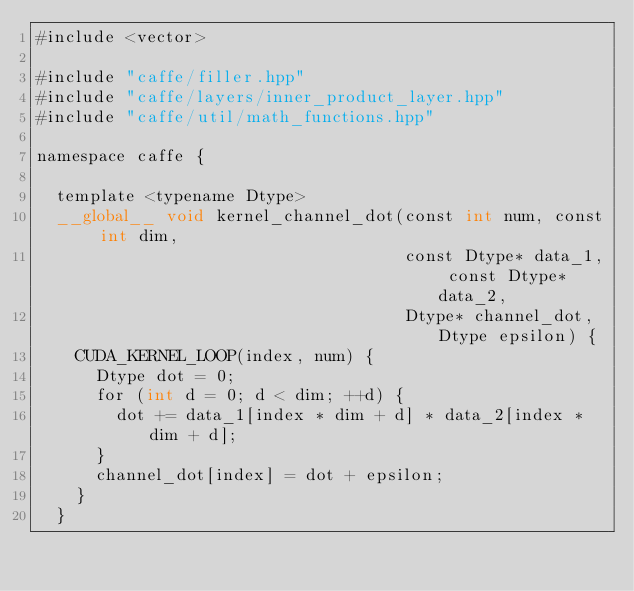<code> <loc_0><loc_0><loc_500><loc_500><_Cuda_>#include <vector>

#include "caffe/filler.hpp"
#include "caffe/layers/inner_product_layer.hpp"
#include "caffe/util/math_functions.hpp"

namespace caffe {

  template <typename Dtype>
  __global__ void kernel_channel_dot(const int num, const int dim,
                                     const Dtype* data_1, const Dtype* data_2,
                                     Dtype* channel_dot, Dtype epsilon) {
    CUDA_KERNEL_LOOP(index, num) {
      Dtype dot = 0;
      for (int d = 0; d < dim; ++d) {
        dot += data_1[index * dim + d] * data_2[index * dim + d];
      }
      channel_dot[index] = dot + epsilon;
    }
  }
</code> 